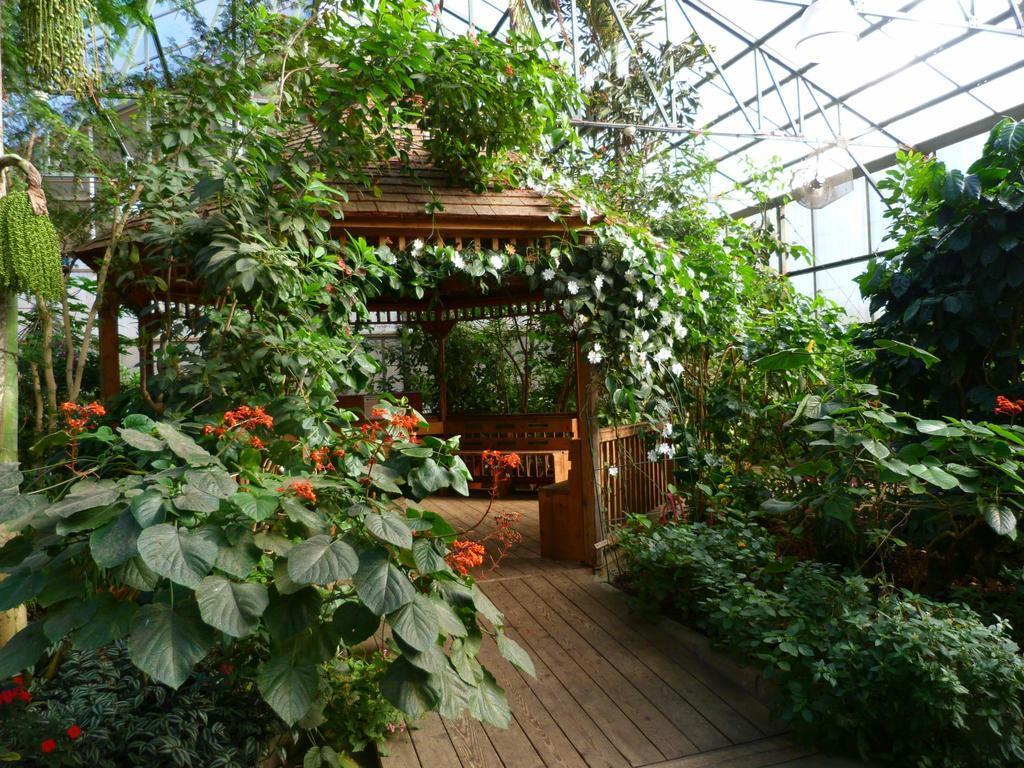In one or two sentences, can you explain what this image depicts? In the image we can see some plants. Behind them there is a arch. At the top of the image there is roof. 